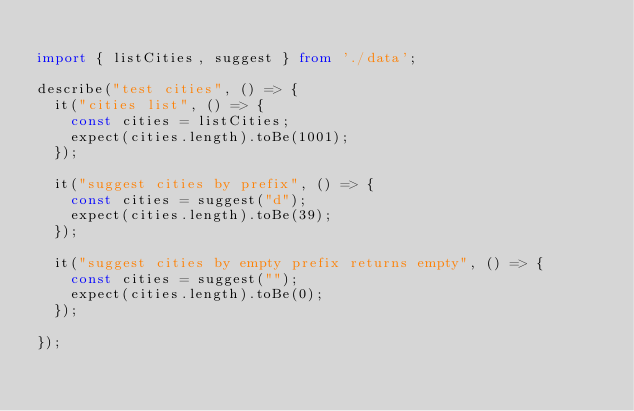<code> <loc_0><loc_0><loc_500><loc_500><_TypeScript_>
import { listCities, suggest } from './data';

describe("test cities", () => {
  it("cities list", () => {
    const cities = listCities;
    expect(cities.length).toBe(1001);
  });

  it("suggest cities by prefix", () => {
    const cities = suggest("d");
    expect(cities.length).toBe(39);
  });

  it("suggest cities by empty prefix returns empty", () => {
    const cities = suggest("");
    expect(cities.length).toBe(0);
  });

});</code> 